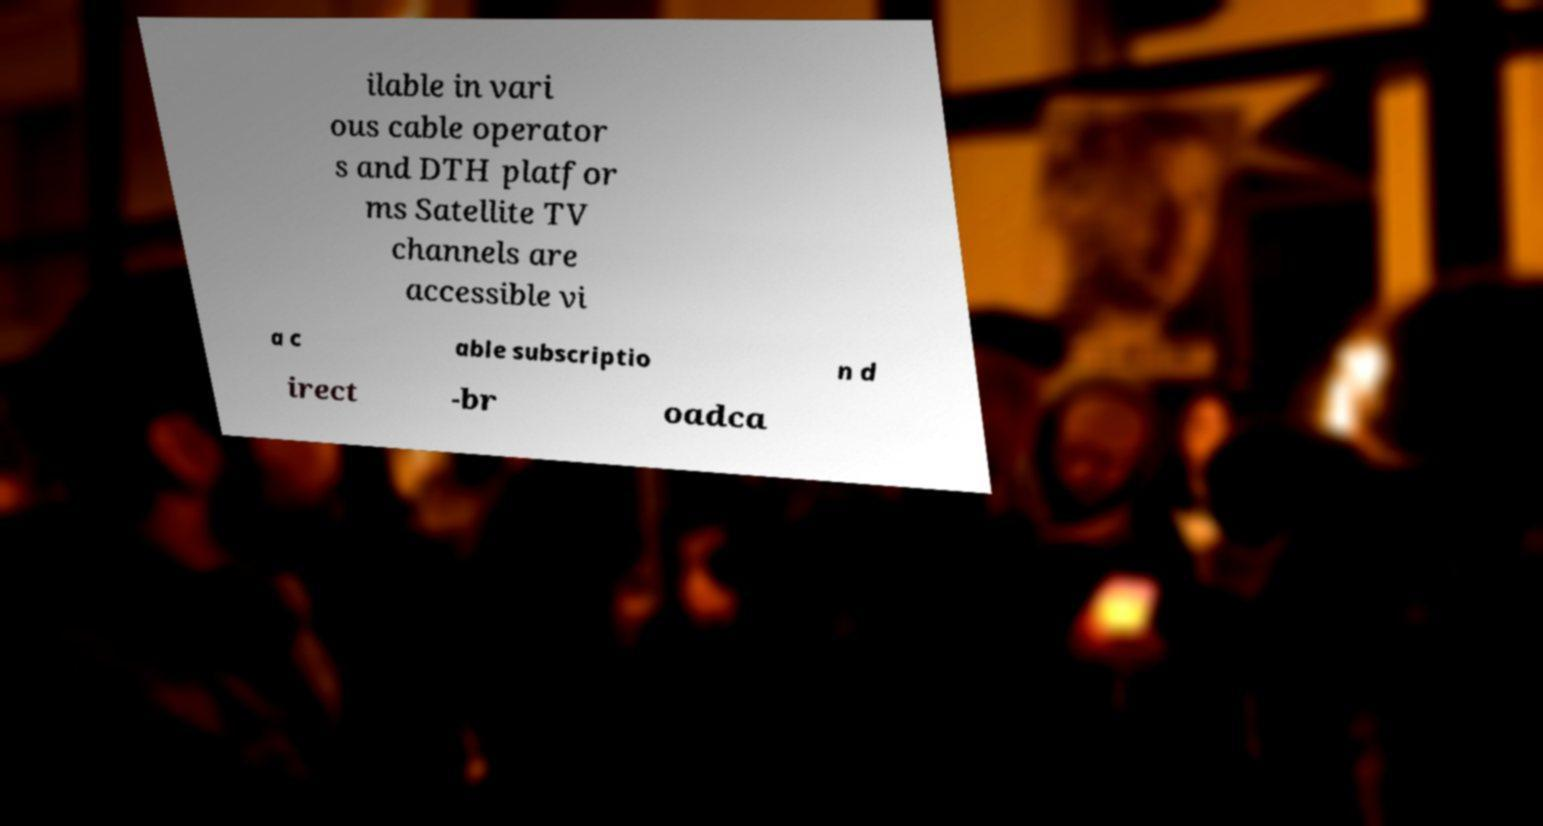Could you extract and type out the text from this image? ilable in vari ous cable operator s and DTH platfor ms Satellite TV channels are accessible vi a c able subscriptio n d irect -br oadca 